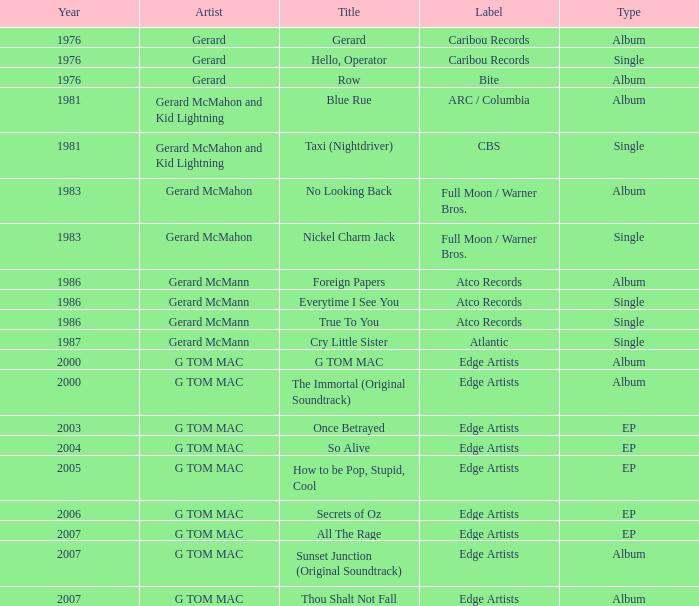Name the Year which has a Label of atco records and a Type of album? Question 2 1986.0. 